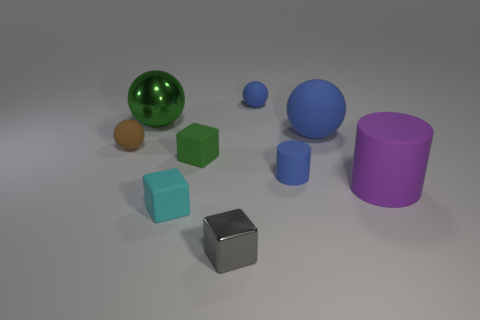What number of other objects are the same color as the small matte cylinder?
Ensure brevity in your answer.  2. Do the object behind the green metallic object and the big green shiny ball have the same size?
Your answer should be very brief. No. What number of things are small balls left of the small gray shiny thing or things to the right of the large green ball?
Make the answer very short. 8. There is a large ball right of the green metallic thing; is its color the same as the metal block?
Offer a very short reply. No. What number of rubber objects are either cyan objects or tiny red objects?
Offer a terse response. 1. What is the shape of the large purple matte thing?
Your answer should be compact. Cylinder. Is there anything else that has the same material as the large green thing?
Keep it short and to the point. Yes. Is the large blue object made of the same material as the blue cylinder?
Offer a very short reply. Yes. Is there a small blue matte sphere right of the tiny cyan matte thing that is on the left side of the matte cylinder in front of the tiny blue matte cylinder?
Offer a very short reply. Yes. How many other objects are the same shape as the brown thing?
Provide a short and direct response. 3. 